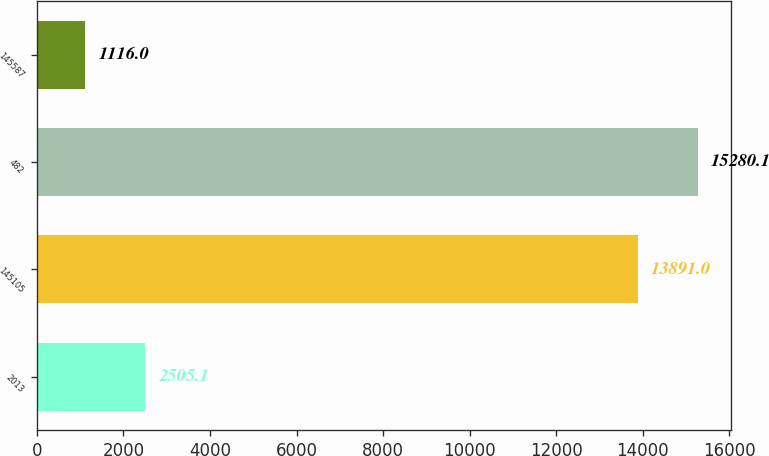Convert chart to OTSL. <chart><loc_0><loc_0><loc_500><loc_500><bar_chart><fcel>2013<fcel>145105<fcel>482<fcel>145587<nl><fcel>2505.1<fcel>13891<fcel>15280.1<fcel>1116<nl></chart> 